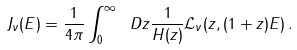Convert formula to latex. <formula><loc_0><loc_0><loc_500><loc_500>J _ { \nu } ( E ) = \frac { 1 } { 4 \pi } \int _ { 0 } ^ { \infty } \ D z \frac { 1 } { H ( z ) } \mathcal { L } _ { \nu } ( z , ( 1 + z ) E ) \, .</formula> 